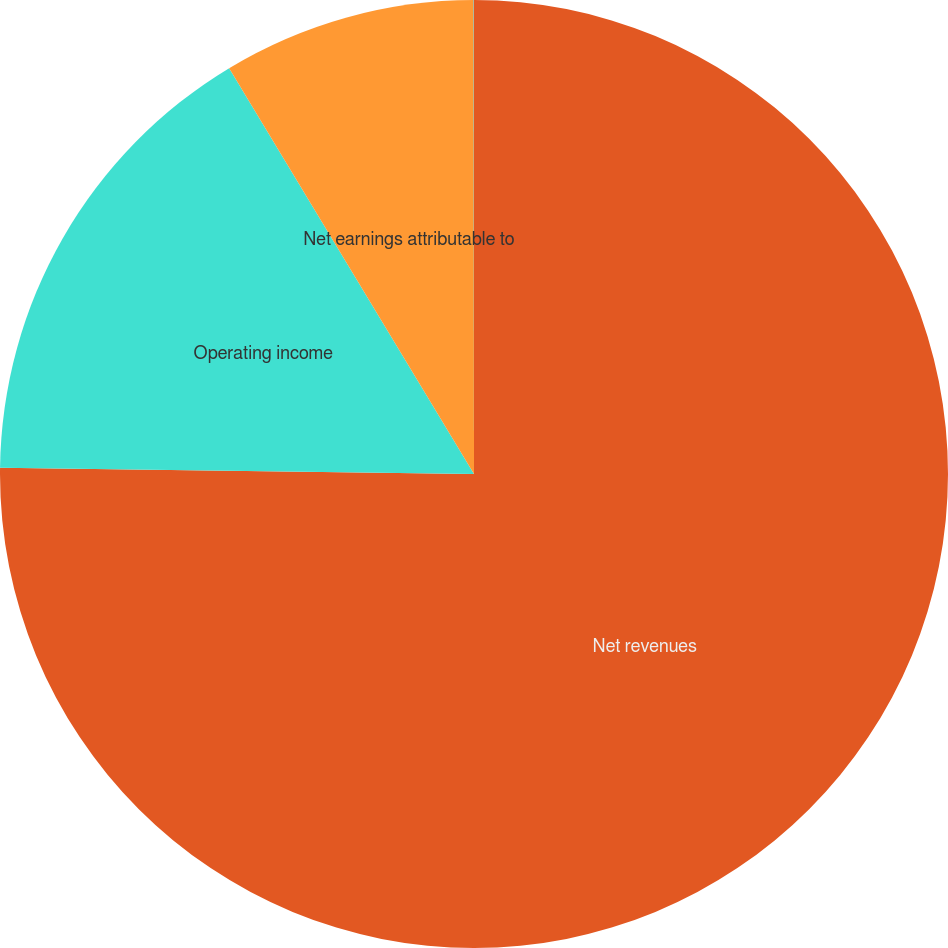Convert chart. <chart><loc_0><loc_0><loc_500><loc_500><pie_chart><fcel>Net revenues<fcel>Operating income<fcel>Net earnings attributable to<fcel>EPS - diluted<nl><fcel>75.22%<fcel>16.15%<fcel>8.63%<fcel>0.01%<nl></chart> 